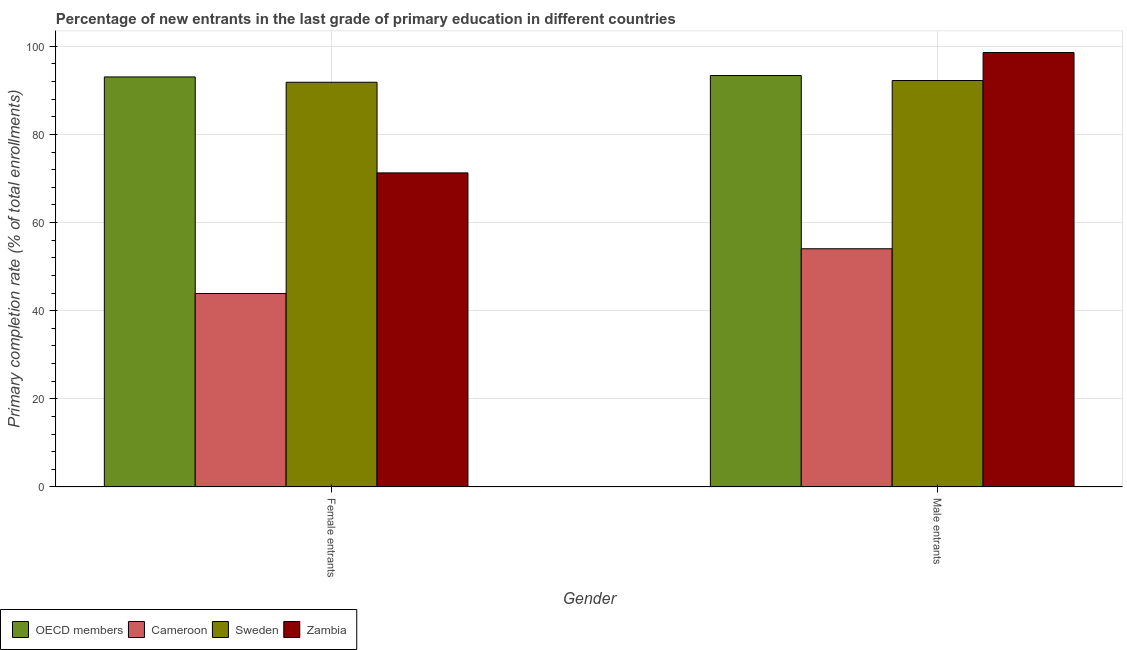How many groups of bars are there?
Provide a short and direct response. 2. Are the number of bars on each tick of the X-axis equal?
Provide a succinct answer. Yes. How many bars are there on the 1st tick from the right?
Ensure brevity in your answer.  4. What is the label of the 2nd group of bars from the left?
Provide a short and direct response. Male entrants. What is the primary completion rate of female entrants in Cameroon?
Offer a terse response. 43.9. Across all countries, what is the maximum primary completion rate of male entrants?
Offer a terse response. 98.57. Across all countries, what is the minimum primary completion rate of female entrants?
Offer a terse response. 43.9. In which country was the primary completion rate of female entrants maximum?
Keep it short and to the point. OECD members. In which country was the primary completion rate of female entrants minimum?
Provide a short and direct response. Cameroon. What is the total primary completion rate of female entrants in the graph?
Offer a terse response. 300.04. What is the difference between the primary completion rate of male entrants in OECD members and that in Zambia?
Your answer should be compact. -5.22. What is the difference between the primary completion rate of female entrants in Cameroon and the primary completion rate of male entrants in Zambia?
Ensure brevity in your answer.  -54.67. What is the average primary completion rate of female entrants per country?
Make the answer very short. 75.01. What is the difference between the primary completion rate of female entrants and primary completion rate of male entrants in OECD members?
Ensure brevity in your answer.  -0.31. What is the ratio of the primary completion rate of male entrants in Sweden to that in OECD members?
Make the answer very short. 0.99. Is the primary completion rate of male entrants in Zambia less than that in Cameroon?
Your response must be concise. No. What does the 2nd bar from the right in Male entrants represents?
Offer a terse response. Sweden. How many bars are there?
Keep it short and to the point. 8. How many countries are there in the graph?
Your answer should be very brief. 4. What is the difference between two consecutive major ticks on the Y-axis?
Provide a short and direct response. 20. Does the graph contain grids?
Keep it short and to the point. Yes. How many legend labels are there?
Make the answer very short. 4. What is the title of the graph?
Offer a terse response. Percentage of new entrants in the last grade of primary education in different countries. Does "Greenland" appear as one of the legend labels in the graph?
Make the answer very short. No. What is the label or title of the Y-axis?
Provide a short and direct response. Primary completion rate (% of total enrollments). What is the Primary completion rate (% of total enrollments) of OECD members in Female entrants?
Offer a very short reply. 93.04. What is the Primary completion rate (% of total enrollments) in Cameroon in Female entrants?
Make the answer very short. 43.9. What is the Primary completion rate (% of total enrollments) of Sweden in Female entrants?
Your response must be concise. 91.83. What is the Primary completion rate (% of total enrollments) in Zambia in Female entrants?
Provide a succinct answer. 71.27. What is the Primary completion rate (% of total enrollments) of OECD members in Male entrants?
Keep it short and to the point. 93.35. What is the Primary completion rate (% of total enrollments) in Cameroon in Male entrants?
Ensure brevity in your answer.  54.05. What is the Primary completion rate (% of total enrollments) of Sweden in Male entrants?
Give a very brief answer. 92.22. What is the Primary completion rate (% of total enrollments) of Zambia in Male entrants?
Give a very brief answer. 98.57. Across all Gender, what is the maximum Primary completion rate (% of total enrollments) in OECD members?
Offer a terse response. 93.35. Across all Gender, what is the maximum Primary completion rate (% of total enrollments) of Cameroon?
Ensure brevity in your answer.  54.05. Across all Gender, what is the maximum Primary completion rate (% of total enrollments) of Sweden?
Make the answer very short. 92.22. Across all Gender, what is the maximum Primary completion rate (% of total enrollments) of Zambia?
Your answer should be compact. 98.57. Across all Gender, what is the minimum Primary completion rate (% of total enrollments) of OECD members?
Your answer should be very brief. 93.04. Across all Gender, what is the minimum Primary completion rate (% of total enrollments) of Cameroon?
Make the answer very short. 43.9. Across all Gender, what is the minimum Primary completion rate (% of total enrollments) of Sweden?
Keep it short and to the point. 91.83. Across all Gender, what is the minimum Primary completion rate (% of total enrollments) of Zambia?
Your answer should be very brief. 71.27. What is the total Primary completion rate (% of total enrollments) of OECD members in the graph?
Offer a terse response. 186.39. What is the total Primary completion rate (% of total enrollments) of Cameroon in the graph?
Your response must be concise. 97.95. What is the total Primary completion rate (% of total enrollments) in Sweden in the graph?
Provide a succinct answer. 184.06. What is the total Primary completion rate (% of total enrollments) in Zambia in the graph?
Offer a very short reply. 169.84. What is the difference between the Primary completion rate (% of total enrollments) in OECD members in Female entrants and that in Male entrants?
Your answer should be very brief. -0.31. What is the difference between the Primary completion rate (% of total enrollments) in Cameroon in Female entrants and that in Male entrants?
Your response must be concise. -10.15. What is the difference between the Primary completion rate (% of total enrollments) of Sweden in Female entrants and that in Male entrants?
Keep it short and to the point. -0.39. What is the difference between the Primary completion rate (% of total enrollments) of Zambia in Female entrants and that in Male entrants?
Your response must be concise. -27.31. What is the difference between the Primary completion rate (% of total enrollments) in OECD members in Female entrants and the Primary completion rate (% of total enrollments) in Cameroon in Male entrants?
Provide a succinct answer. 38.99. What is the difference between the Primary completion rate (% of total enrollments) in OECD members in Female entrants and the Primary completion rate (% of total enrollments) in Sweden in Male entrants?
Offer a terse response. 0.81. What is the difference between the Primary completion rate (% of total enrollments) of OECD members in Female entrants and the Primary completion rate (% of total enrollments) of Zambia in Male entrants?
Offer a very short reply. -5.54. What is the difference between the Primary completion rate (% of total enrollments) of Cameroon in Female entrants and the Primary completion rate (% of total enrollments) of Sweden in Male entrants?
Offer a terse response. -48.32. What is the difference between the Primary completion rate (% of total enrollments) in Cameroon in Female entrants and the Primary completion rate (% of total enrollments) in Zambia in Male entrants?
Keep it short and to the point. -54.67. What is the difference between the Primary completion rate (% of total enrollments) of Sweden in Female entrants and the Primary completion rate (% of total enrollments) of Zambia in Male entrants?
Give a very brief answer. -6.74. What is the average Primary completion rate (% of total enrollments) in OECD members per Gender?
Offer a very short reply. 93.19. What is the average Primary completion rate (% of total enrollments) of Cameroon per Gender?
Your answer should be compact. 48.98. What is the average Primary completion rate (% of total enrollments) in Sweden per Gender?
Offer a terse response. 92.03. What is the average Primary completion rate (% of total enrollments) of Zambia per Gender?
Provide a short and direct response. 84.92. What is the difference between the Primary completion rate (% of total enrollments) of OECD members and Primary completion rate (% of total enrollments) of Cameroon in Female entrants?
Provide a short and direct response. 49.14. What is the difference between the Primary completion rate (% of total enrollments) of OECD members and Primary completion rate (% of total enrollments) of Sweden in Female entrants?
Offer a terse response. 1.21. What is the difference between the Primary completion rate (% of total enrollments) of OECD members and Primary completion rate (% of total enrollments) of Zambia in Female entrants?
Provide a short and direct response. 21.77. What is the difference between the Primary completion rate (% of total enrollments) of Cameroon and Primary completion rate (% of total enrollments) of Sweden in Female entrants?
Give a very brief answer. -47.93. What is the difference between the Primary completion rate (% of total enrollments) in Cameroon and Primary completion rate (% of total enrollments) in Zambia in Female entrants?
Your answer should be compact. -27.37. What is the difference between the Primary completion rate (% of total enrollments) of Sweden and Primary completion rate (% of total enrollments) of Zambia in Female entrants?
Your answer should be very brief. 20.56. What is the difference between the Primary completion rate (% of total enrollments) in OECD members and Primary completion rate (% of total enrollments) in Cameroon in Male entrants?
Ensure brevity in your answer.  39.3. What is the difference between the Primary completion rate (% of total enrollments) of OECD members and Primary completion rate (% of total enrollments) of Sweden in Male entrants?
Offer a terse response. 1.13. What is the difference between the Primary completion rate (% of total enrollments) of OECD members and Primary completion rate (% of total enrollments) of Zambia in Male entrants?
Provide a succinct answer. -5.22. What is the difference between the Primary completion rate (% of total enrollments) of Cameroon and Primary completion rate (% of total enrollments) of Sweden in Male entrants?
Your response must be concise. -38.17. What is the difference between the Primary completion rate (% of total enrollments) of Cameroon and Primary completion rate (% of total enrollments) of Zambia in Male entrants?
Your answer should be compact. -44.52. What is the difference between the Primary completion rate (% of total enrollments) in Sweden and Primary completion rate (% of total enrollments) in Zambia in Male entrants?
Your answer should be very brief. -6.35. What is the ratio of the Primary completion rate (% of total enrollments) in OECD members in Female entrants to that in Male entrants?
Keep it short and to the point. 1. What is the ratio of the Primary completion rate (% of total enrollments) in Cameroon in Female entrants to that in Male entrants?
Provide a succinct answer. 0.81. What is the ratio of the Primary completion rate (% of total enrollments) in Sweden in Female entrants to that in Male entrants?
Your response must be concise. 1. What is the ratio of the Primary completion rate (% of total enrollments) of Zambia in Female entrants to that in Male entrants?
Your answer should be very brief. 0.72. What is the difference between the highest and the second highest Primary completion rate (% of total enrollments) of OECD members?
Give a very brief answer. 0.31. What is the difference between the highest and the second highest Primary completion rate (% of total enrollments) of Cameroon?
Offer a terse response. 10.15. What is the difference between the highest and the second highest Primary completion rate (% of total enrollments) of Sweden?
Ensure brevity in your answer.  0.39. What is the difference between the highest and the second highest Primary completion rate (% of total enrollments) in Zambia?
Offer a very short reply. 27.31. What is the difference between the highest and the lowest Primary completion rate (% of total enrollments) of OECD members?
Your answer should be compact. 0.31. What is the difference between the highest and the lowest Primary completion rate (% of total enrollments) of Cameroon?
Your answer should be compact. 10.15. What is the difference between the highest and the lowest Primary completion rate (% of total enrollments) of Sweden?
Make the answer very short. 0.39. What is the difference between the highest and the lowest Primary completion rate (% of total enrollments) in Zambia?
Keep it short and to the point. 27.31. 